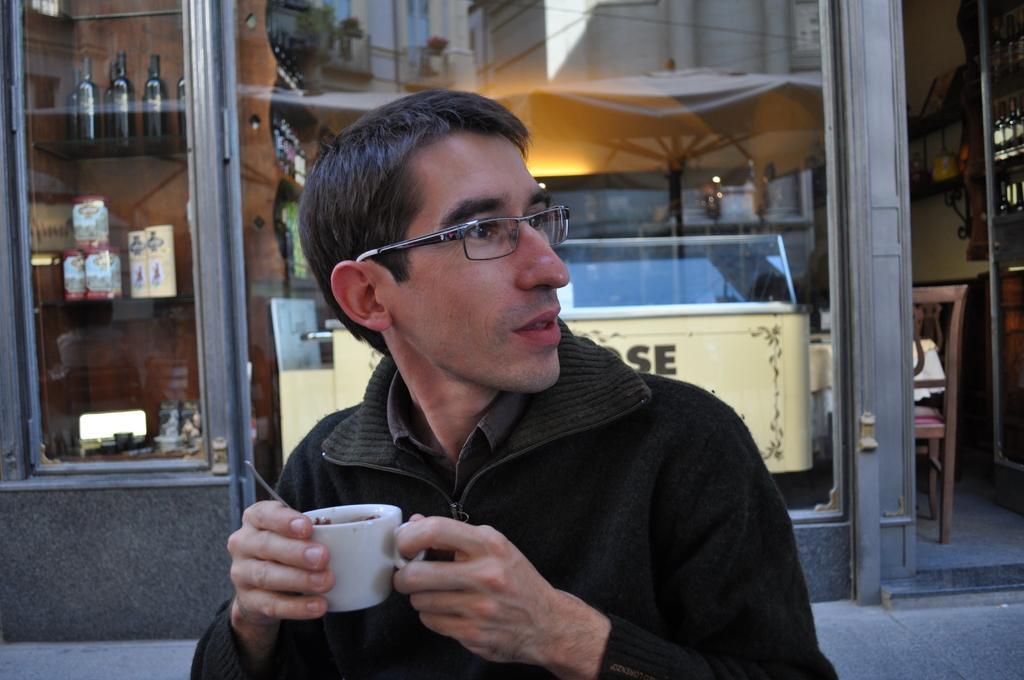How would you summarize this image in a sentence or two? In this image we can see a man wearing spectacles on his face is holding a cup in his hands. In the background we can see a glass window through which bottles are seen. 